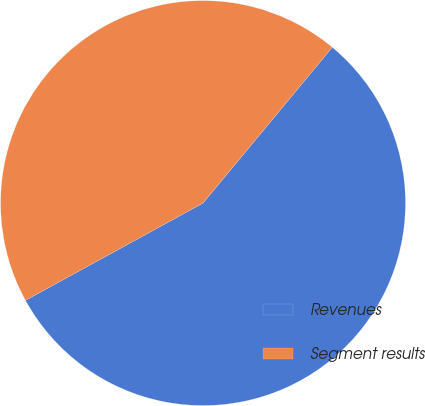Convert chart. <chart><loc_0><loc_0><loc_500><loc_500><pie_chart><fcel>Revenues<fcel>Segment results<nl><fcel>56.0%<fcel>44.0%<nl></chart> 